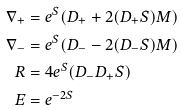<formula> <loc_0><loc_0><loc_500><loc_500>\nabla _ { + } & = e ^ { S } ( D _ { + } + 2 ( D _ { + } S ) M ) \\ \nabla _ { - } & = e ^ { S } ( D _ { - } - 2 ( D _ { - } S ) M ) \\ R & = 4 e ^ { S } ( D _ { - } D _ { + } S ) \\ E & = e ^ { - 2 S }</formula> 